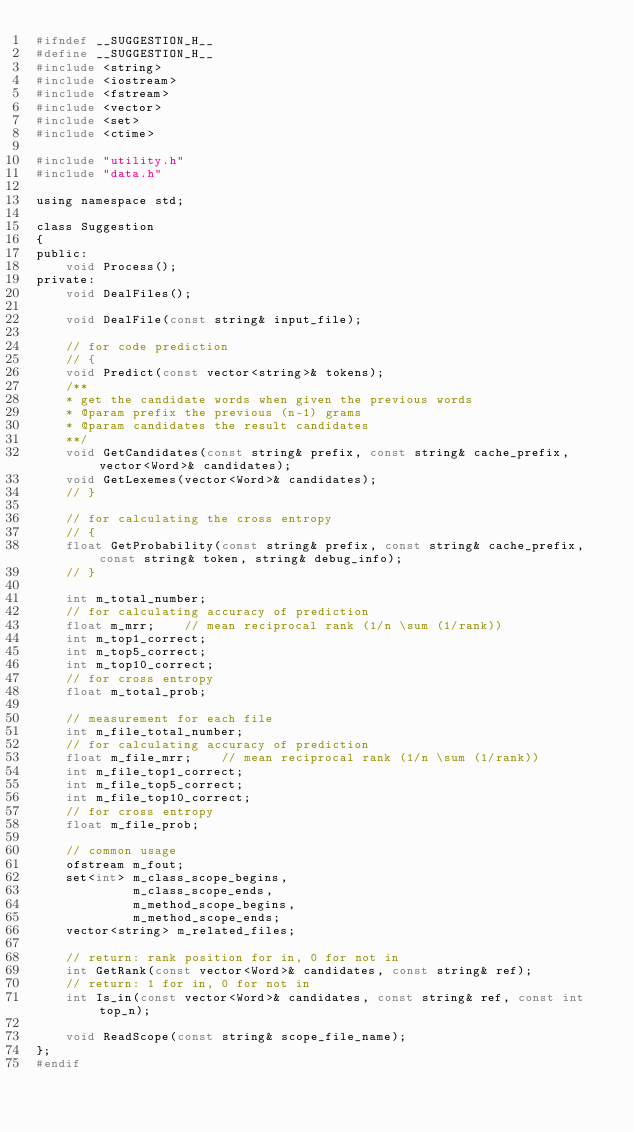Convert code to text. <code><loc_0><loc_0><loc_500><loc_500><_C_>#ifndef __SUGGESTION_H__
#define __SUGGESTION_H__
#include <string>
#include <iostream>
#include <fstream>
#include <vector>
#include <set>
#include <ctime>

#include "utility.h"
#include "data.h"

using namespace std;

class Suggestion
{
public:
    void Process();
private:
    void DealFiles();

    void DealFile(const string& input_file);

    // for code prediction
    // {
    void Predict(const vector<string>& tokens);
    /**
    * get the candidate words when given the previous words
    * @param prefix the previous (n-1) grams
    * @param candidates the result candidates
    **/
	void GetCandidates(const string& prefix, const string& cache_prefix, vector<Word>& candidates);
    void GetLexemes(vector<Word>& candidates);
    // }
 
    // for calculating the cross entropy
    // {
    float GetProbability(const string& prefix, const string& cache_prefix, const string& token, string& debug_info);
    // }
   
    int m_total_number;
    // for calculating accuracy of prediction
    float m_mrr;    // mean reciprocal rank (1/n \sum (1/rank))
    int m_top1_correct;
    int m_top5_correct;
    int m_top10_correct;
    // for cross entropy
    float m_total_prob;
    
    // measurement for each file
    int m_file_total_number;
    // for calculating accuracy of prediction
    float m_file_mrr;    // mean reciprocal rank (1/n \sum (1/rank))
    int m_file_top1_correct;
    int m_file_top5_correct;
    int m_file_top10_correct;
    // for cross entropy
    float m_file_prob;

    // common usage
    ofstream m_fout;
    set<int> m_class_scope_begins,
             m_class_scope_ends,
             m_method_scope_begins,
             m_method_scope_ends;
    vector<string> m_related_files;

    // return: rank position for in, 0 for not in
    int GetRank(const vector<Word>& candidates, const string& ref);
    // return: 1 for in, 0 for not in
    int Is_in(const vector<Word>& candidates, const string& ref, const int top_n);

    void ReadScope(const string& scope_file_name);
};
#endif

</code> 